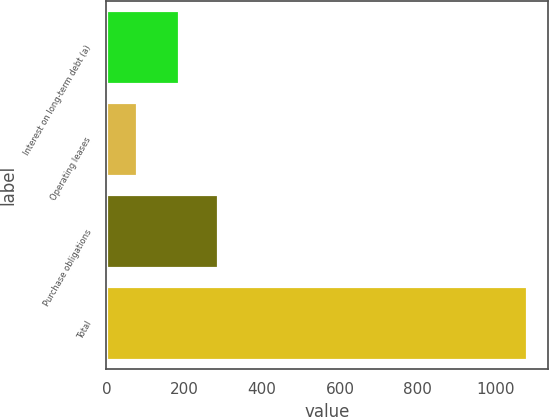<chart> <loc_0><loc_0><loc_500><loc_500><bar_chart><fcel>Interest on long-term debt (a)<fcel>Operating leases<fcel>Purchase obligations<fcel>Total<nl><fcel>186<fcel>78<fcel>286.3<fcel>1081<nl></chart> 